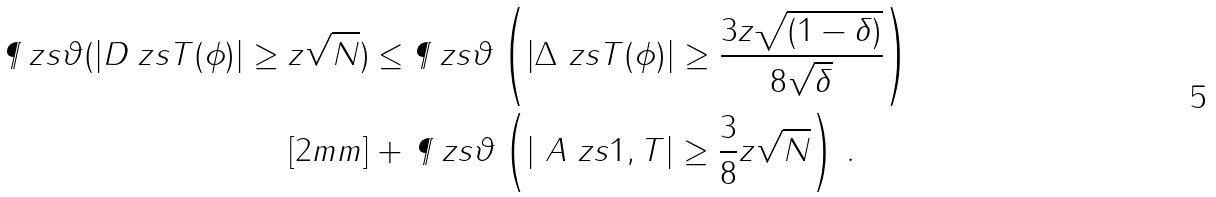<formula> <loc_0><loc_0><loc_500><loc_500>\P _ { \ } z s { \vartheta } ( | D _ { \ } z s { T } ( \phi ) | \geq z \sqrt { N } ) & \leq \P _ { \ } z s { \vartheta } \left ( | \Delta _ { \ } z s { T } ( \phi ) | \geq \frac { 3 z \sqrt { ( 1 - \delta ) } } { 8 \sqrt { \delta } } \right ) \\ [ 2 m m ] & + \, \P _ { \ } z s { \vartheta } \left ( | \ A _ { \ } z s { 1 , T } | \geq \frac { 3 } { 8 } z \sqrt { N } \right ) \, .</formula> 